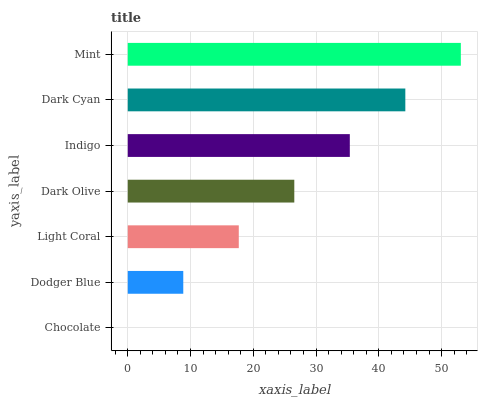Is Chocolate the minimum?
Answer yes or no. Yes. Is Mint the maximum?
Answer yes or no. Yes. Is Dodger Blue the minimum?
Answer yes or no. No. Is Dodger Blue the maximum?
Answer yes or no. No. Is Dodger Blue greater than Chocolate?
Answer yes or no. Yes. Is Chocolate less than Dodger Blue?
Answer yes or no. Yes. Is Chocolate greater than Dodger Blue?
Answer yes or no. No. Is Dodger Blue less than Chocolate?
Answer yes or no. No. Is Dark Olive the high median?
Answer yes or no. Yes. Is Dark Olive the low median?
Answer yes or no. Yes. Is Mint the high median?
Answer yes or no. No. Is Chocolate the low median?
Answer yes or no. No. 